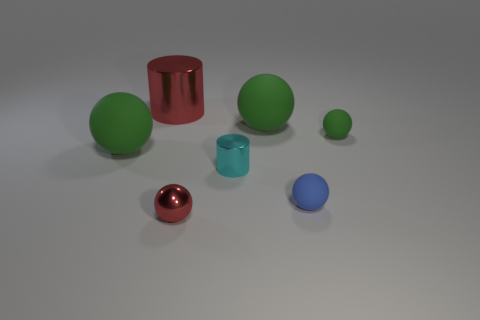How many green balls must be subtracted to get 1 green balls? 2 Subtract all red cylinders. How many green balls are left? 3 Subtract all red spheres. How many spheres are left? 4 Subtract all tiny red spheres. How many spheres are left? 4 Subtract all cyan balls. Subtract all yellow cubes. How many balls are left? 5 Add 1 tiny objects. How many objects exist? 8 Subtract all cylinders. How many objects are left? 5 Add 2 big red cylinders. How many big red cylinders are left? 3 Add 3 metallic cylinders. How many metallic cylinders exist? 5 Subtract 0 green cylinders. How many objects are left? 7 